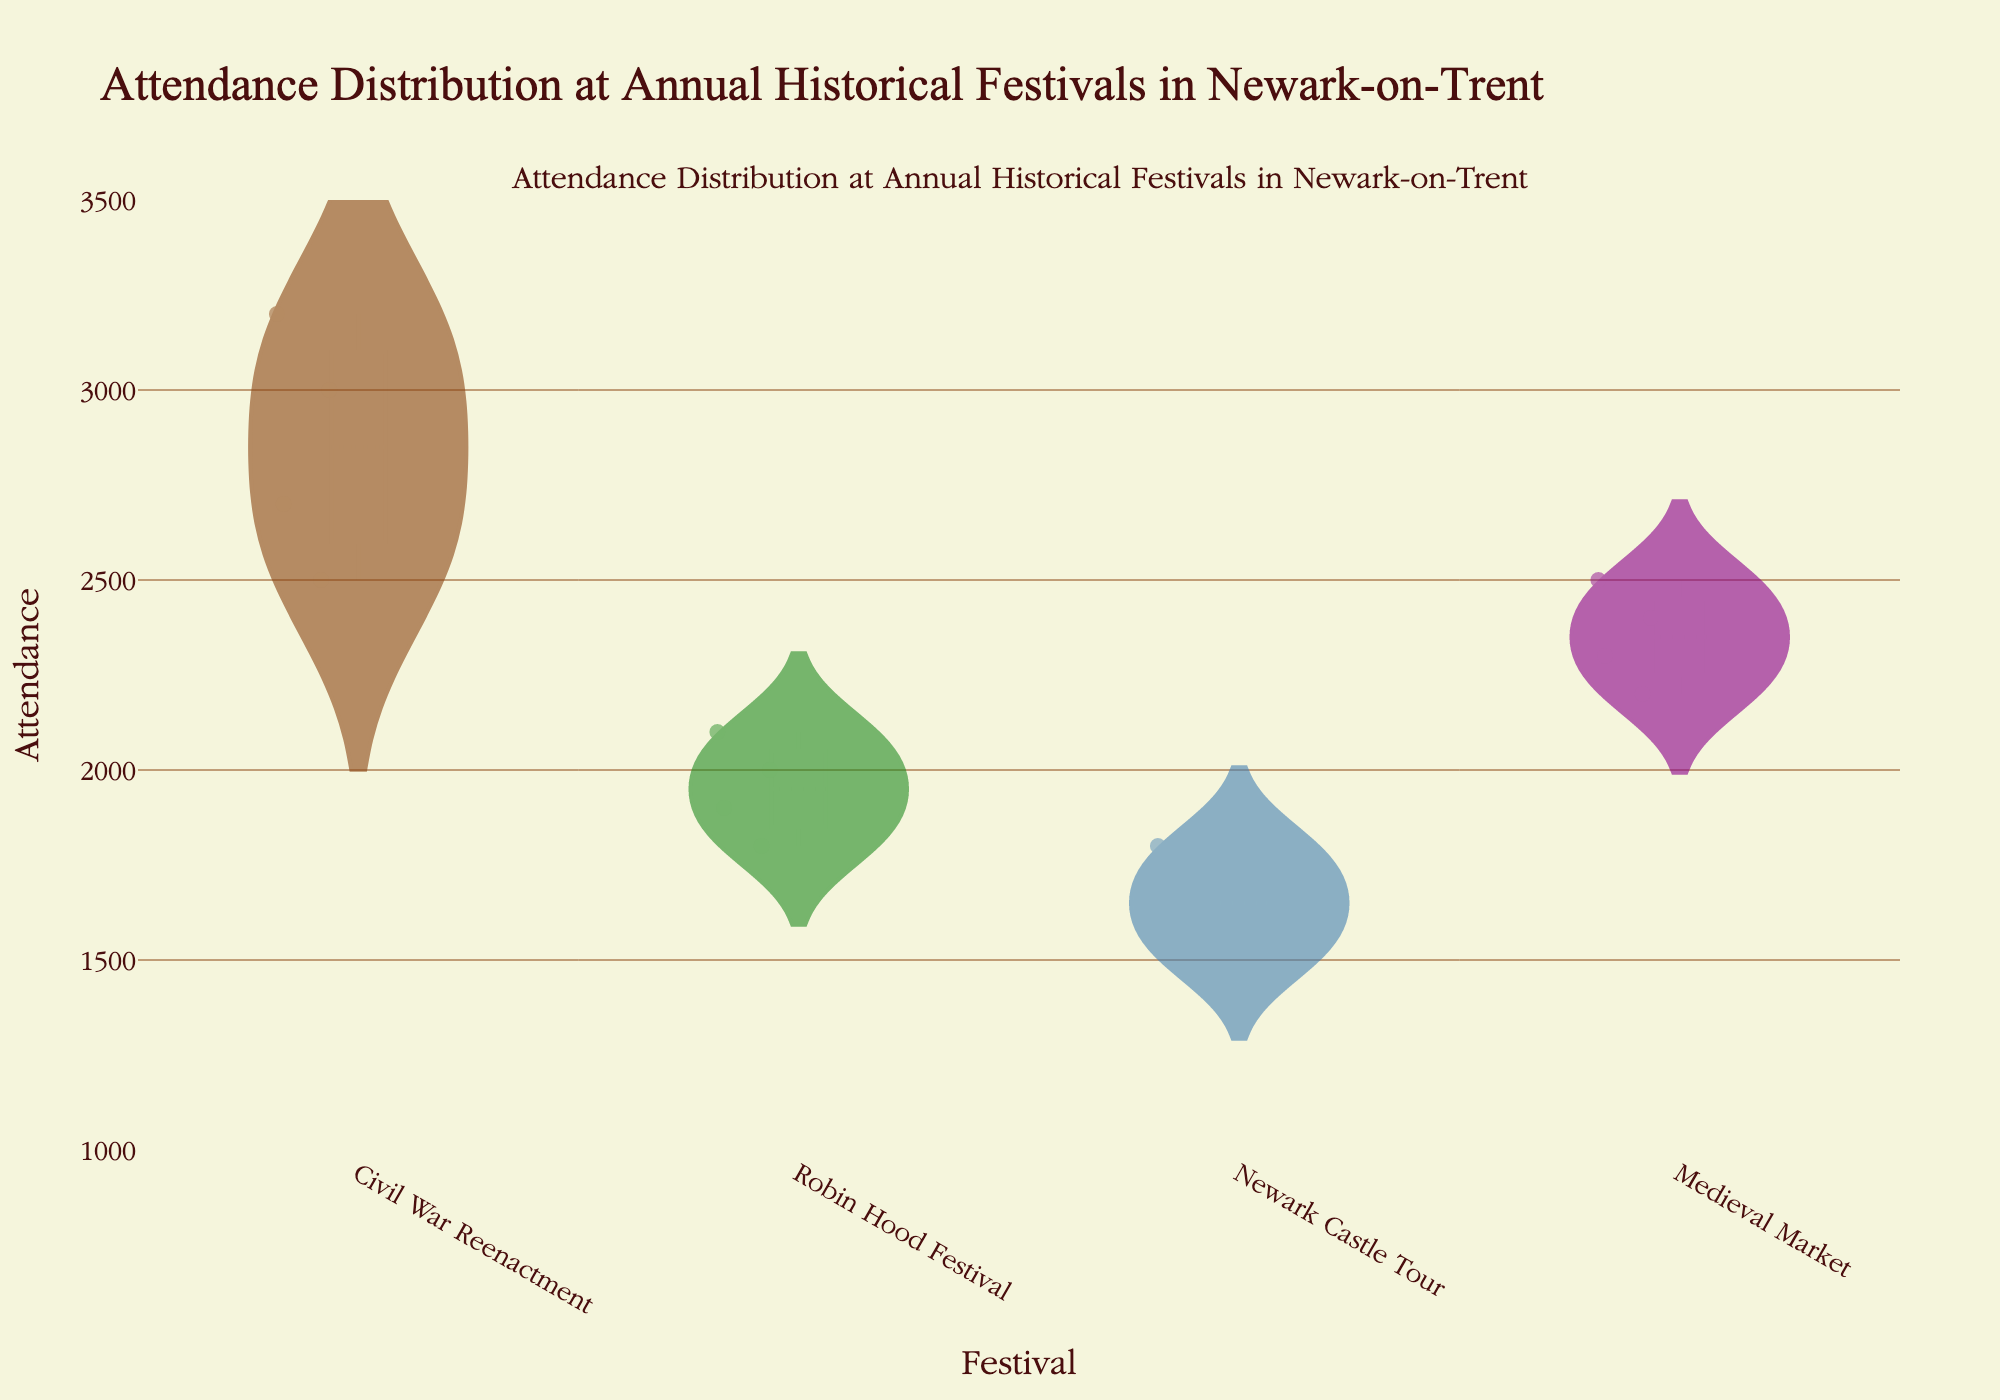What's the title of the figure? The title is usually found at the top of the chart, above the axis labels and data points. In this case, it is written in a distinct font and color as described in the explanation.
Answer: Attendance Distribution at Annual Historical Festivals in Newark-on-Trent Which festival has the highest median attendance? The median line is shown in each violin plot as indicated by the meanline in the code. The highest line among the four plots corresponds to the festival with the highest median.
Answer: Civil War Reenactment How does the attendance distribution of the Medieval Market compare to the Civil War Reenactment? The Civil War Reenactment has a higher median, a wider spread, and generally higher attendance values as seen in the violin plot. The Medieval Market has a narrower range and lower median attendance.
Answer: Civil War Reenactment has higher median and wider spread How many data points are visible for each festival? Each violin plot has one point for each year's attendance data from 2018 to 2022, excluding 2020. Counting the points in each plot will give the total for each festival.
Answer: 4 Which year had the highest attendance for the Robin Hood Festival? By examining the points along the violin plot for the Robin Hood Festival, the highest point will correspond to the year with the highest attendance.
Answer: 2022 What is the interquartile range (IQR) of attendance for Newark Castle Tour in the violin plot? The IQR can be derived from the violin plot by identifying the first and third quartiles of the Newark Castle Tour's attendance data, represented within the box visible within the plot.
Answer: 300 (1600 to 1900) Which festival has the smallest spread in attendance over the years? The spread of attendance is visualized by the width of the violin plot—narrower plots indicate less variability. Comparing the plots shows which one is the narrowest.
Answer: Newark Castle Tour What is the mean attendance for the Civil War Reenactment festival? The mean line visible on the violin plot gives the average attendance. By identifying this line within the Civil War Reenactment plot, we find the value.
Answer: 2850 In which year is there data missing for all festivals? Data points are missing for all festivals in the year not depicted in the violin plots. By analyzing the range of years, the missing year can be identified.
Answer: 2020 